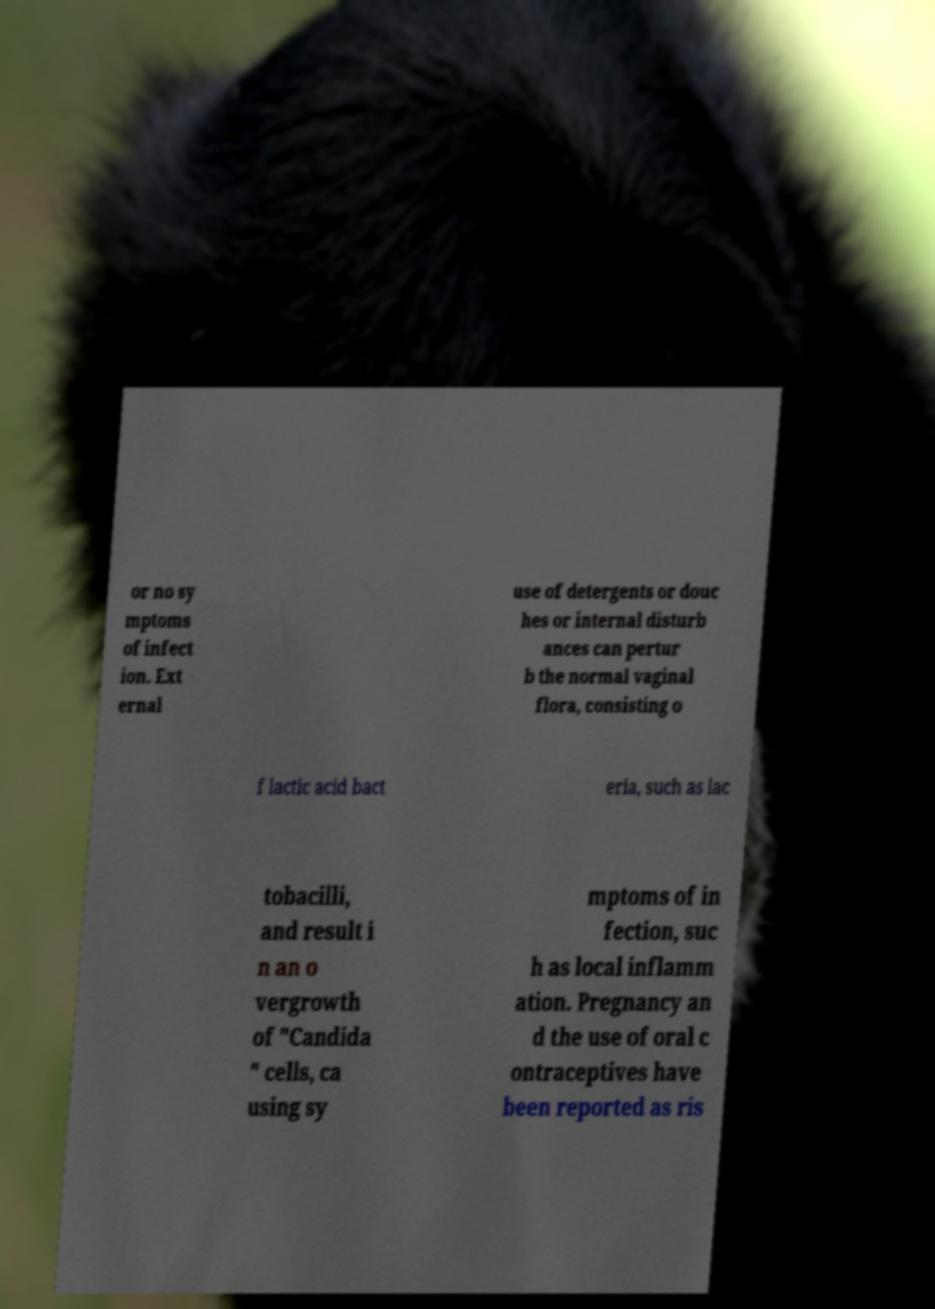For documentation purposes, I need the text within this image transcribed. Could you provide that? or no sy mptoms of infect ion. Ext ernal use of detergents or douc hes or internal disturb ances can pertur b the normal vaginal flora, consisting o f lactic acid bact eria, such as lac tobacilli, and result i n an o vergrowth of "Candida " cells, ca using sy mptoms of in fection, suc h as local inflamm ation. Pregnancy an d the use of oral c ontraceptives have been reported as ris 